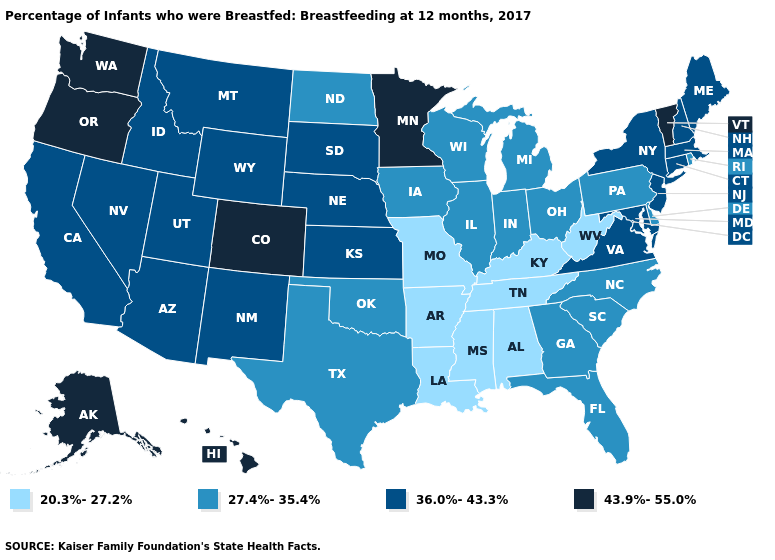What is the value of South Dakota?
Keep it brief. 36.0%-43.3%. What is the value of Nevada?
Be succinct. 36.0%-43.3%. Name the states that have a value in the range 20.3%-27.2%?
Be succinct. Alabama, Arkansas, Kentucky, Louisiana, Mississippi, Missouri, Tennessee, West Virginia. Is the legend a continuous bar?
Answer briefly. No. What is the value of Missouri?
Give a very brief answer. 20.3%-27.2%. What is the value of Rhode Island?
Keep it brief. 27.4%-35.4%. Does Vermont have the highest value in the USA?
Quick response, please. Yes. Name the states that have a value in the range 20.3%-27.2%?
Quick response, please. Alabama, Arkansas, Kentucky, Louisiana, Mississippi, Missouri, Tennessee, West Virginia. Which states have the lowest value in the USA?
Short answer required. Alabama, Arkansas, Kentucky, Louisiana, Mississippi, Missouri, Tennessee, West Virginia. Does Hawaii have the highest value in the USA?
Answer briefly. Yes. Name the states that have a value in the range 36.0%-43.3%?
Concise answer only. Arizona, California, Connecticut, Idaho, Kansas, Maine, Maryland, Massachusetts, Montana, Nebraska, Nevada, New Hampshire, New Jersey, New Mexico, New York, South Dakota, Utah, Virginia, Wyoming. Does Arizona have the lowest value in the USA?
Keep it brief. No. What is the value of Alaska?
Give a very brief answer. 43.9%-55.0%. What is the lowest value in the South?
Write a very short answer. 20.3%-27.2%. What is the value of Mississippi?
Write a very short answer. 20.3%-27.2%. 